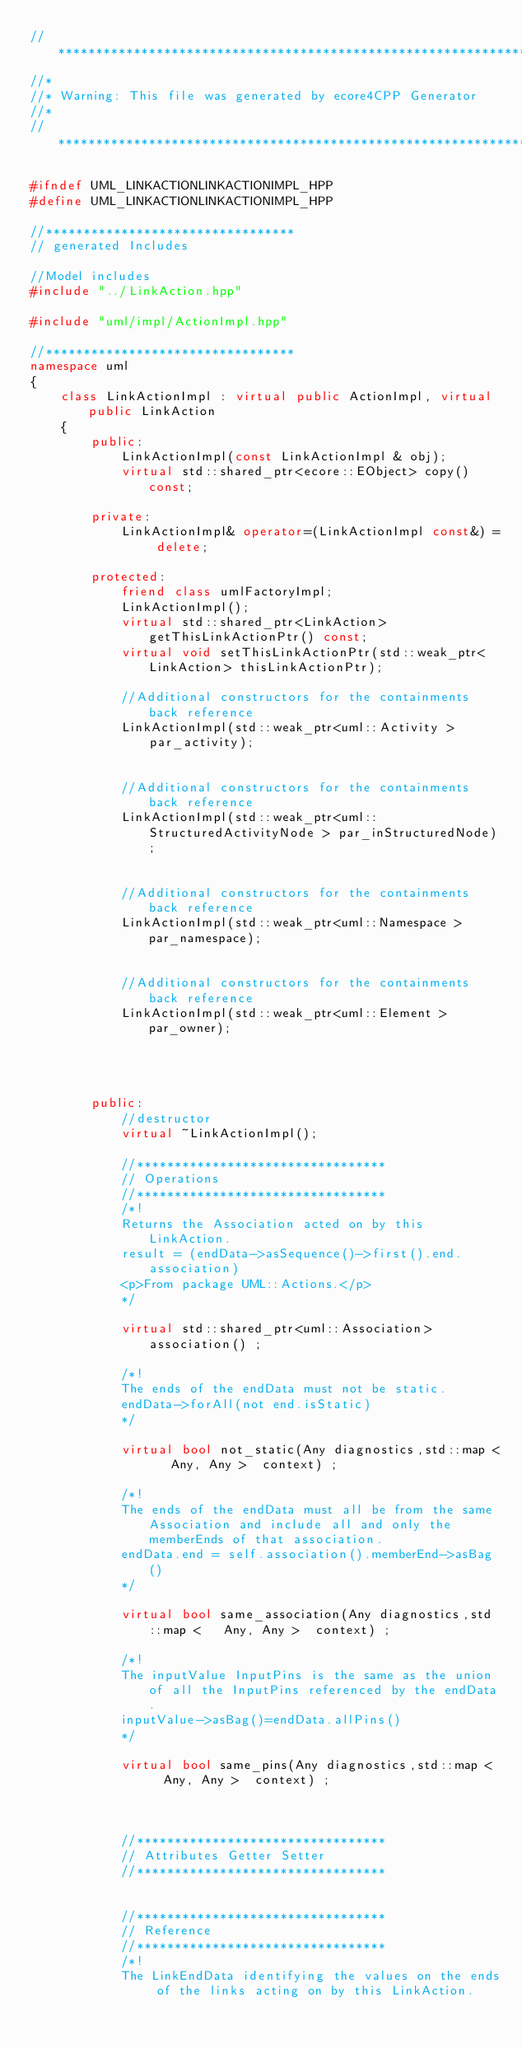<code> <loc_0><loc_0><loc_500><loc_500><_C++_>//********************************************************************
//*    
//* Warning: This file was generated by ecore4CPP Generator
//*
//********************************************************************

#ifndef UML_LINKACTIONLINKACTIONIMPL_HPP
#define UML_LINKACTIONLINKACTIONIMPL_HPP

//*********************************
// generated Includes

//Model includes
#include "../LinkAction.hpp"

#include "uml/impl/ActionImpl.hpp"

//*********************************
namespace uml 
{
	class LinkActionImpl : virtual public ActionImpl, virtual public LinkAction 
	{
		public: 
			LinkActionImpl(const LinkActionImpl & obj);
			virtual std::shared_ptr<ecore::EObject> copy() const;

		private:    
			LinkActionImpl& operator=(LinkActionImpl const&) = delete;

		protected:
			friend class umlFactoryImpl;
			LinkActionImpl();
			virtual std::shared_ptr<LinkAction> getThisLinkActionPtr() const;
			virtual void setThisLinkActionPtr(std::weak_ptr<LinkAction> thisLinkActionPtr);

			//Additional constructors for the containments back reference
			LinkActionImpl(std::weak_ptr<uml::Activity > par_activity);


			//Additional constructors for the containments back reference
			LinkActionImpl(std::weak_ptr<uml::StructuredActivityNode > par_inStructuredNode);


			//Additional constructors for the containments back reference
			LinkActionImpl(std::weak_ptr<uml::Namespace > par_namespace);


			//Additional constructors for the containments back reference
			LinkActionImpl(std::weak_ptr<uml::Element > par_owner);




		public:
			//destructor
			virtual ~LinkActionImpl();
			
			//*********************************
			// Operations
			//*********************************
			/*!
			Returns the Association acted on by this LinkAction.
			result = (endData->asSequence()->first().end.association)
			<p>From package UML::Actions.</p>
			*/
			 
			virtual std::shared_ptr<uml::Association> association() ;
			
			/*!
			The ends of the endData must not be static.
			endData->forAll(not end.isStatic)
			*/
			 
			virtual bool not_static(Any diagnostics,std::map <   Any, Any >  context) ;
			
			/*!
			The ends of the endData must all be from the same Association and include all and only the memberEnds of that association.
			endData.end = self.association().memberEnd->asBag()
			*/
			 
			virtual bool same_association(Any diagnostics,std::map <   Any, Any >  context) ;
			
			/*!
			The inputValue InputPins is the same as the union of all the InputPins referenced by the endData.
			inputValue->asBag()=endData.allPins()
			*/
			 
			virtual bool same_pins(Any diagnostics,std::map <   Any, Any >  context) ;
			
			
			
			//*********************************
			// Attributes Getter Setter
			//*********************************
			
			
			//*********************************
			// Reference
			//*********************************
			/*!
			The LinkEndData identifying the values on the ends of the links acting on by this LinkAction.</code> 